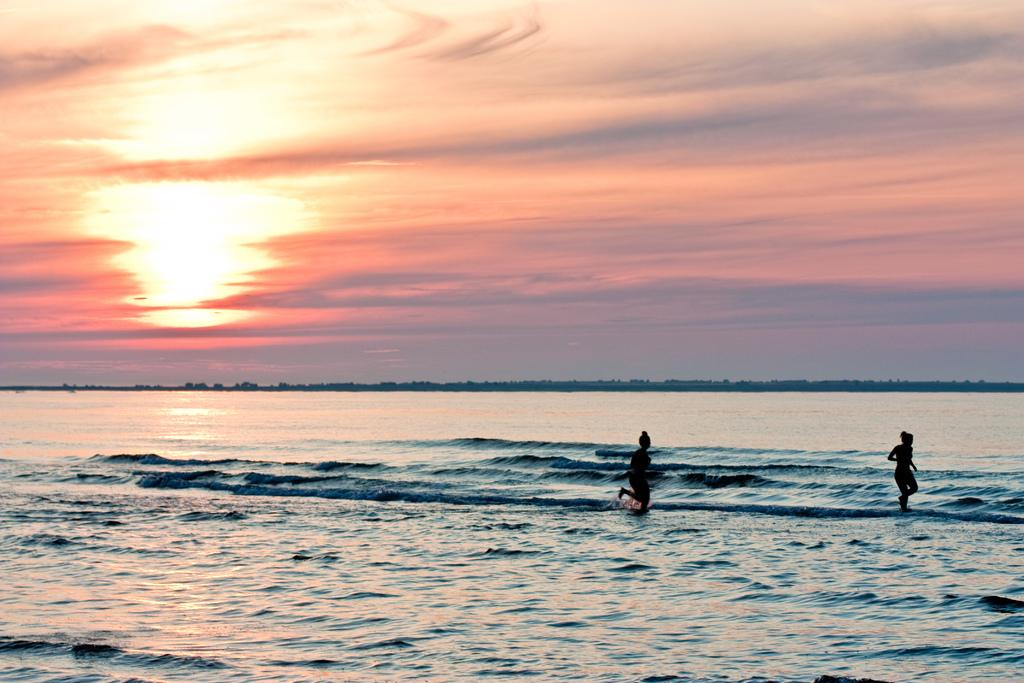How many people are in the image? There are two persons in the image. What is the natural feature present in the image? There is a river in the image. What can be seen in the background of the image? The sky is visible in the background of the image. What is the condition of the sky in the image? The sky has an orange color and there are clouds in it. What type of hook can be seen hanging from the tree in the image? There is no tree or hook present in the image. Is there a hammer visible in the hands of one of the persons in the image? There is no hammer visible in the image; only two persons are present. 